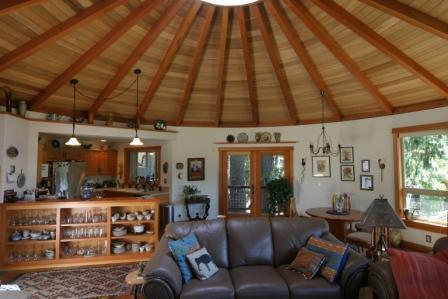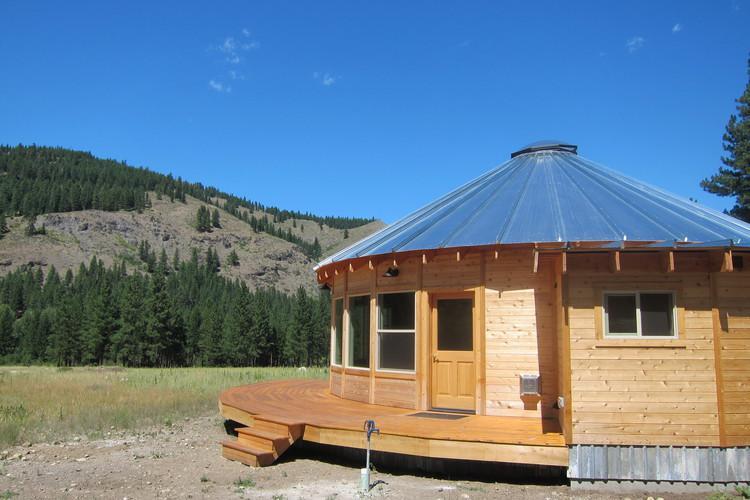The first image is the image on the left, the second image is the image on the right. Given the left and right images, does the statement "The exterior of a round building has a covered deck with a railing in front." hold true? Answer yes or no. No. 